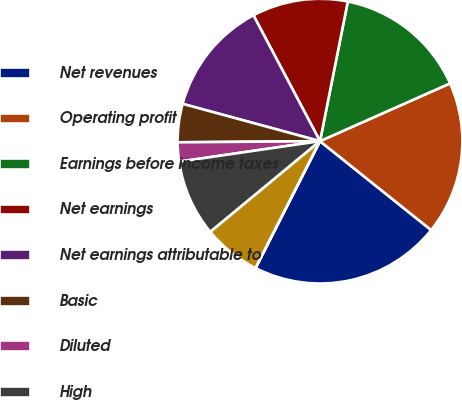Convert chart to OTSL. <chart><loc_0><loc_0><loc_500><loc_500><pie_chart><fcel>Net revenues<fcel>Operating profit<fcel>Earnings before income taxes<fcel>Net earnings<fcel>Net earnings attributable to<fcel>Basic<fcel>Diluted<fcel>High<fcel>Low<fcel>Cash dividends declared<nl><fcel>21.74%<fcel>17.39%<fcel>15.22%<fcel>10.87%<fcel>13.04%<fcel>4.35%<fcel>2.17%<fcel>8.7%<fcel>6.52%<fcel>0.0%<nl></chart> 